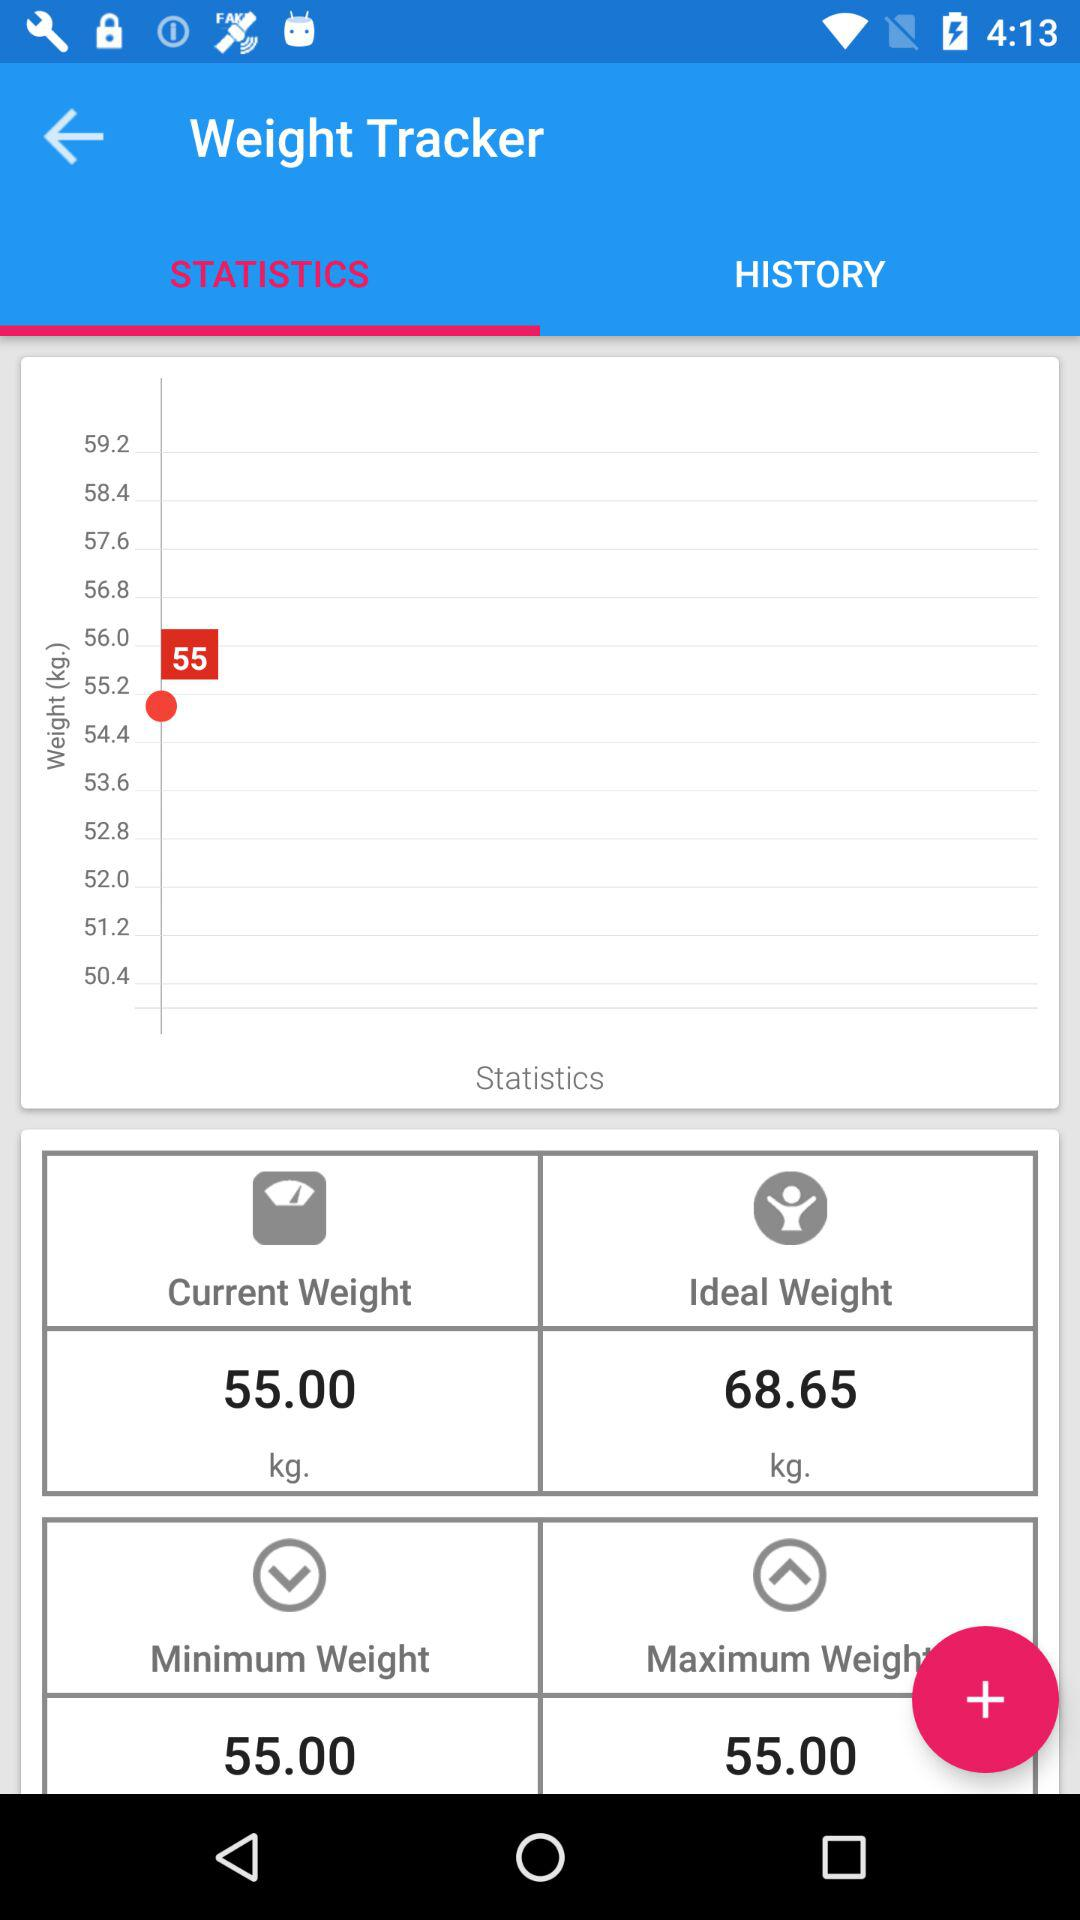What is the current weight? The current weight is 55 kg. 